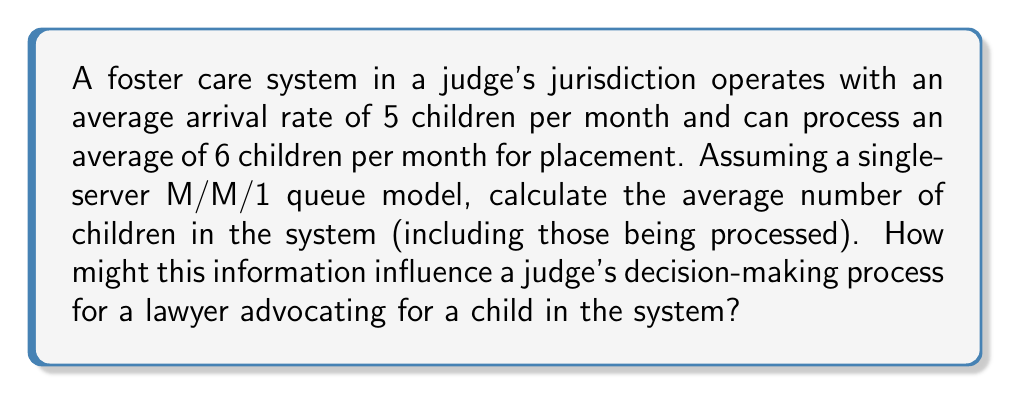Could you help me with this problem? To solve this problem, we'll use the M/M/1 queueing theory model:

1. Define variables:
   $\lambda$ = arrival rate = 5 children/month
   $\mu$ = service rate = 6 children/month

2. Calculate the utilization factor $\rho$:
   $$\rho = \frac{\lambda}{\mu} = \frac{5}{6} \approx 0.833$$

3. The average number of children in the system (L) is given by the formula:
   $$L = \frac{\rho}{1-\rho}$$

4. Substitute the calculated $\rho$:
   $$L = \frac{0.833}{1-0.833} = \frac{0.833}{0.167} \approx 4.988$$

5. Round to two decimal places:
   $$L \approx 4.99$$

This result indicates that, on average, there are about 5 children in the foster care system at any given time. A judge might use this information to:

a) Assess the system's current capacity and efficiency
b) Prioritize cases based on the system's workload
c) Make informed decisions about resource allocation
d) Consider alternative placement options if the system is nearing capacity

A lawyer advocating for a child could use this data to argue for expedited processing or special consideration, especially if the child has unique needs or circumstances.
Answer: 4.99 children 